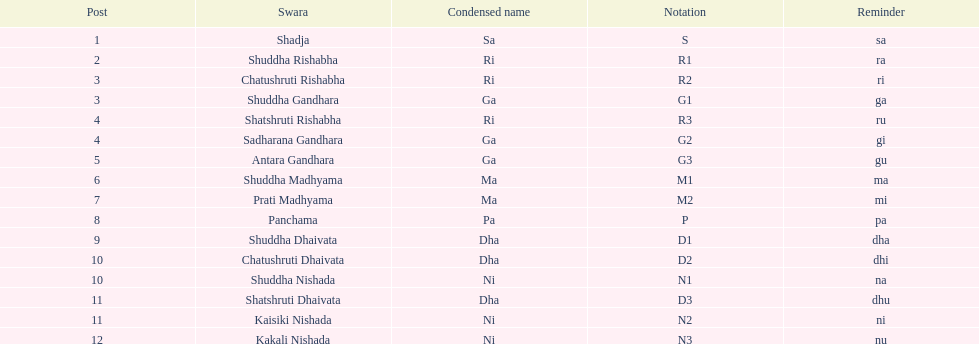What swara is above shatshruti dhaivata? Shuddha Nishada. 